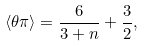<formula> <loc_0><loc_0><loc_500><loc_500>\left < \theta \pi \right > = \frac { 6 } { 3 + n } + \frac { 3 } { 2 } ,</formula> 